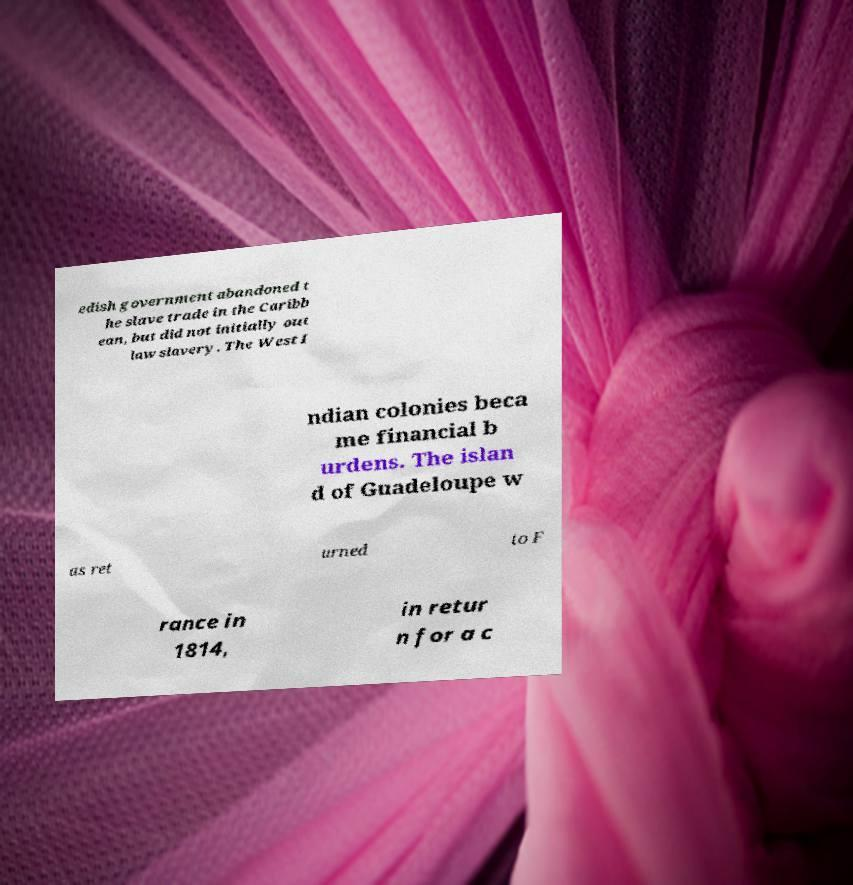Please identify and transcribe the text found in this image. edish government abandoned t he slave trade in the Caribb ean, but did not initially out law slavery. The West I ndian colonies beca me financial b urdens. The islan d of Guadeloupe w as ret urned to F rance in 1814, in retur n for a c 